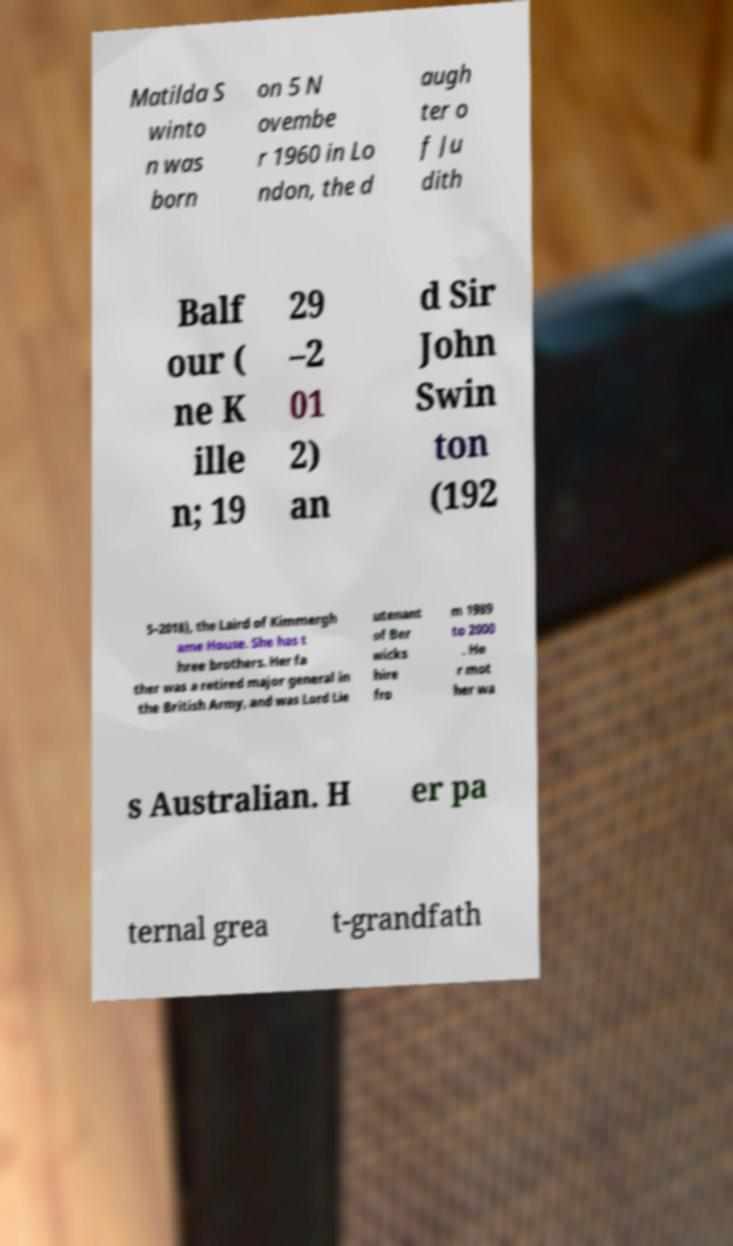There's text embedded in this image that I need extracted. Can you transcribe it verbatim? Matilda S winto n was born on 5 N ovembe r 1960 in Lo ndon, the d augh ter o f Ju dith Balf our ( ne K ille n; 19 29 –2 01 2) an d Sir John Swin ton (192 5–2018), the Laird of Kimmergh ame House. She has t hree brothers. Her fa ther was a retired major general in the British Army, and was Lord Lie utenant of Ber wicks hire fro m 1989 to 2000 . He r mot her wa s Australian. H er pa ternal grea t-grandfath 